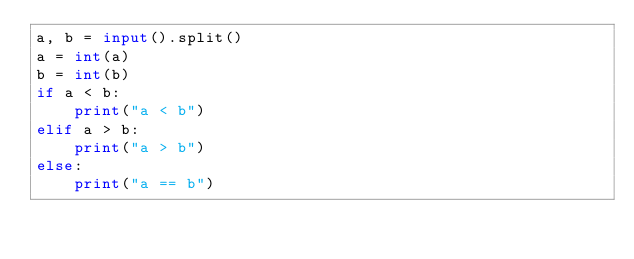Convert code to text. <code><loc_0><loc_0><loc_500><loc_500><_Python_>a, b = input().split()
a = int(a)
b = int(b)
if a < b:
    print("a < b")
elif a > b:
    print("a > b")
else:
    print("a == b")
</code> 